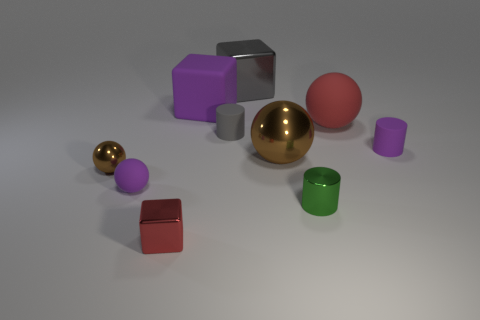What number of other objects are the same shape as the green shiny object?
Your answer should be very brief. 2. How many objects are either purple matte things to the right of the small red block or shiny spheres to the left of the gray rubber object?
Provide a succinct answer. 3. What is the size of the purple thing that is both to the right of the red shiny block and to the left of the purple rubber cylinder?
Ensure brevity in your answer.  Large. There is a rubber thing in front of the small purple cylinder; is it the same shape as the small brown shiny object?
Ensure brevity in your answer.  Yes. There is a red thing that is behind the red object that is on the left side of the red thing that is right of the large brown object; how big is it?
Offer a very short reply. Large. What size is the thing that is the same color as the big matte sphere?
Your answer should be compact. Small. How many objects are either red blocks or blue rubber objects?
Ensure brevity in your answer.  1. What is the shape of the metallic object that is both in front of the small brown metallic object and right of the red cube?
Give a very brief answer. Cylinder. There is a small green thing; is its shape the same as the tiny purple thing that is in front of the tiny purple cylinder?
Your answer should be very brief. No. There is a tiny brown thing; are there any tiny matte objects to the left of it?
Provide a short and direct response. No. 